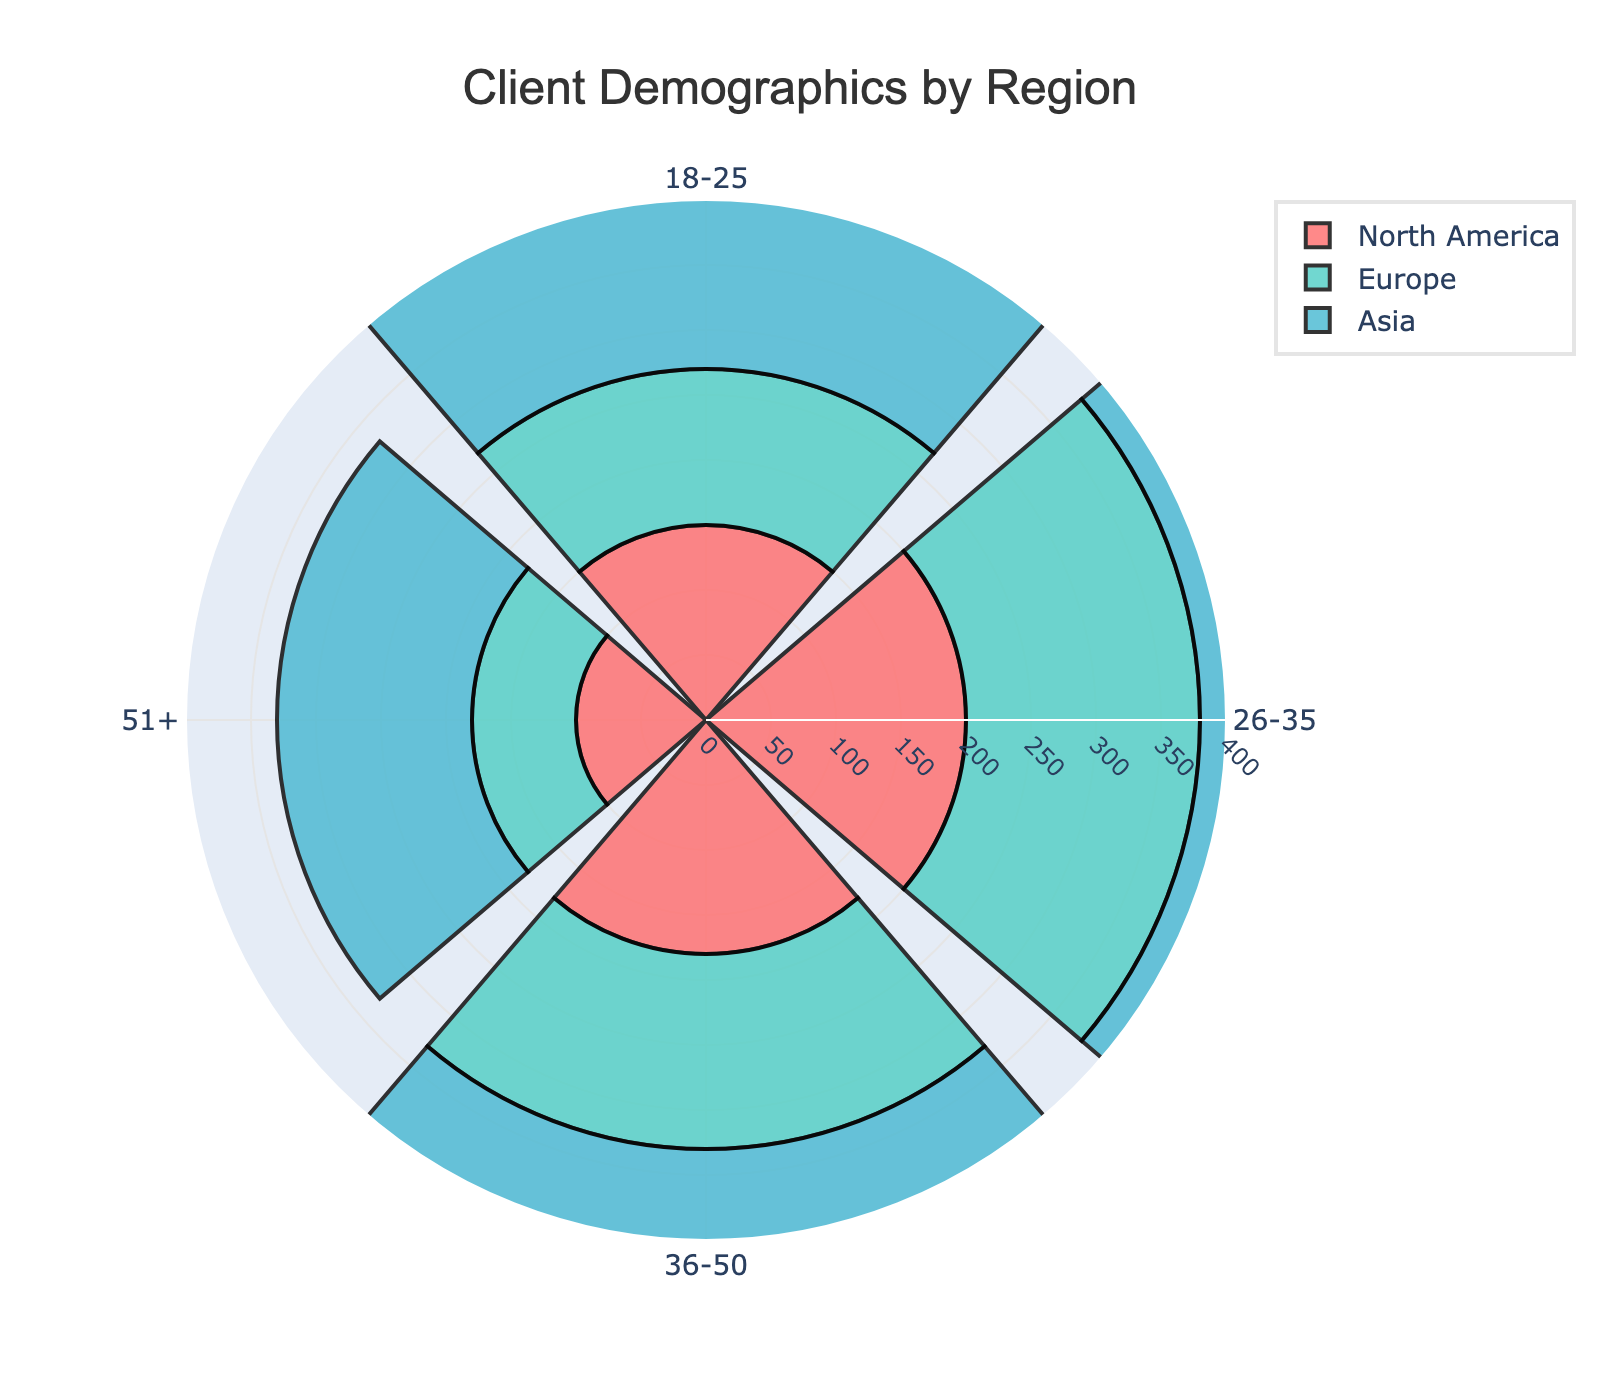how many regions are compared in the figure? The figure compares client demographics by region. By observing the legend, we can count the number of distinct regions each shown in a different color.
Answer: three what is the title of the figure? The title is positioned at the top center of the figure and specifies what the data visualization represents.
Answer: Client Demographics by Region which age group has the highest number of clients in Asia? By comparing the lengths of the bars for each age group in Asia, the longest bar will represent the highest number of clients.
Answer: 26-35 how many age groups are represented in the figure? By looking at the angular axis of the polar chart, we can count the distinct segments representing different age groups.
Answer: four what is the combined number of clients in the age group 36-50 across all regions? Sum the data points representing the 36-50 age group from North America, Europe, and Asia: 180 + 150 + 250.
Answer: 580 which region has the smallest number of clients aged 51+? Compare the bars for the 51+ age group across all regions and find the shortest one.
Answer: Europe how does the number of clients aged 18-25 in North America compare to Europe? Look at the bars for the 18-25 age group in both North America and Europe and compare their lengths: 150 vs. 120.
Answer: higher in North America what percentage of the total clients in Asia are aged 51+? Calculate the sum of clients across all age groups in Asia and then find the percentage that is aged 51+: (150 / (300 + 350 + 250 + 150)) * 100.
Answer: 14.3% which age group shows the most balanced distribution across all regions? Observe the relative lengths of the bars across all regions for each age group and identify the group with minimal differences in bar lengths.
Answer: 26-35 what is the ratio of clients aged 18-25 to 26-35 in Europe? Divide the number of clients aged 18-25 by those aged 26-35 in Europe: 120/180.
Answer: 2:3 